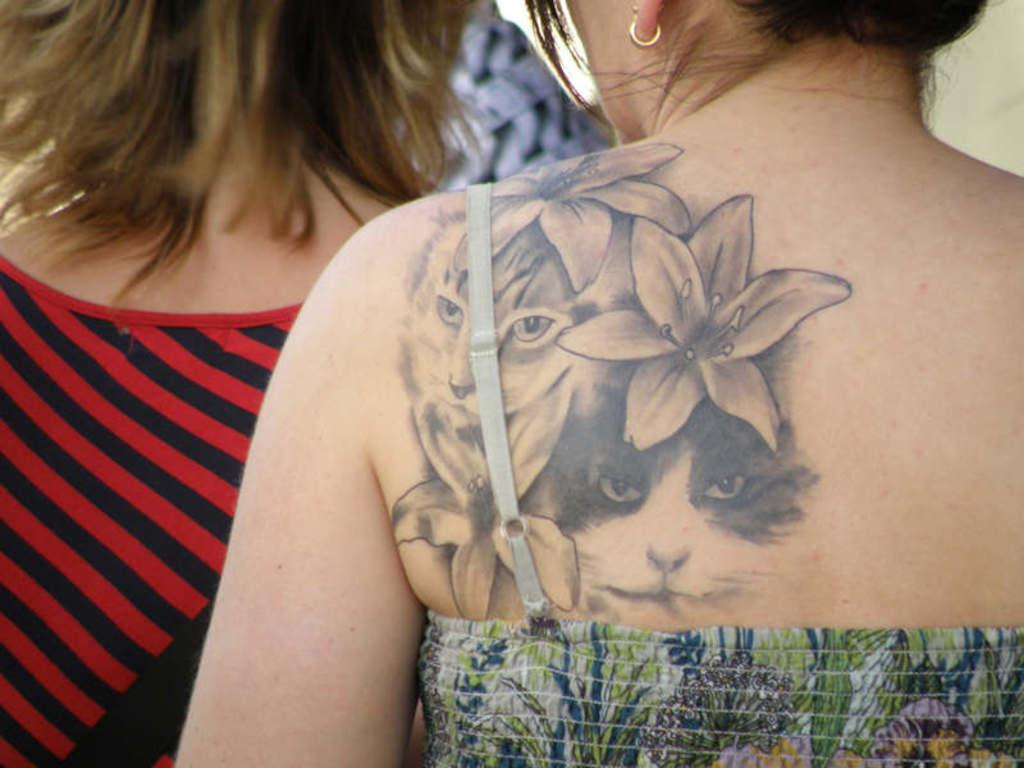How many people are in the image? There are two persons in the image. Can you describe any distinguishing features of one of the persons? One of the persons has a tattoo on their skin. What type of floor can be seen in the image? There is no information about the floor in the image, as the facts provided only mention the presence of two persons and the tattoo on one person's skin. 